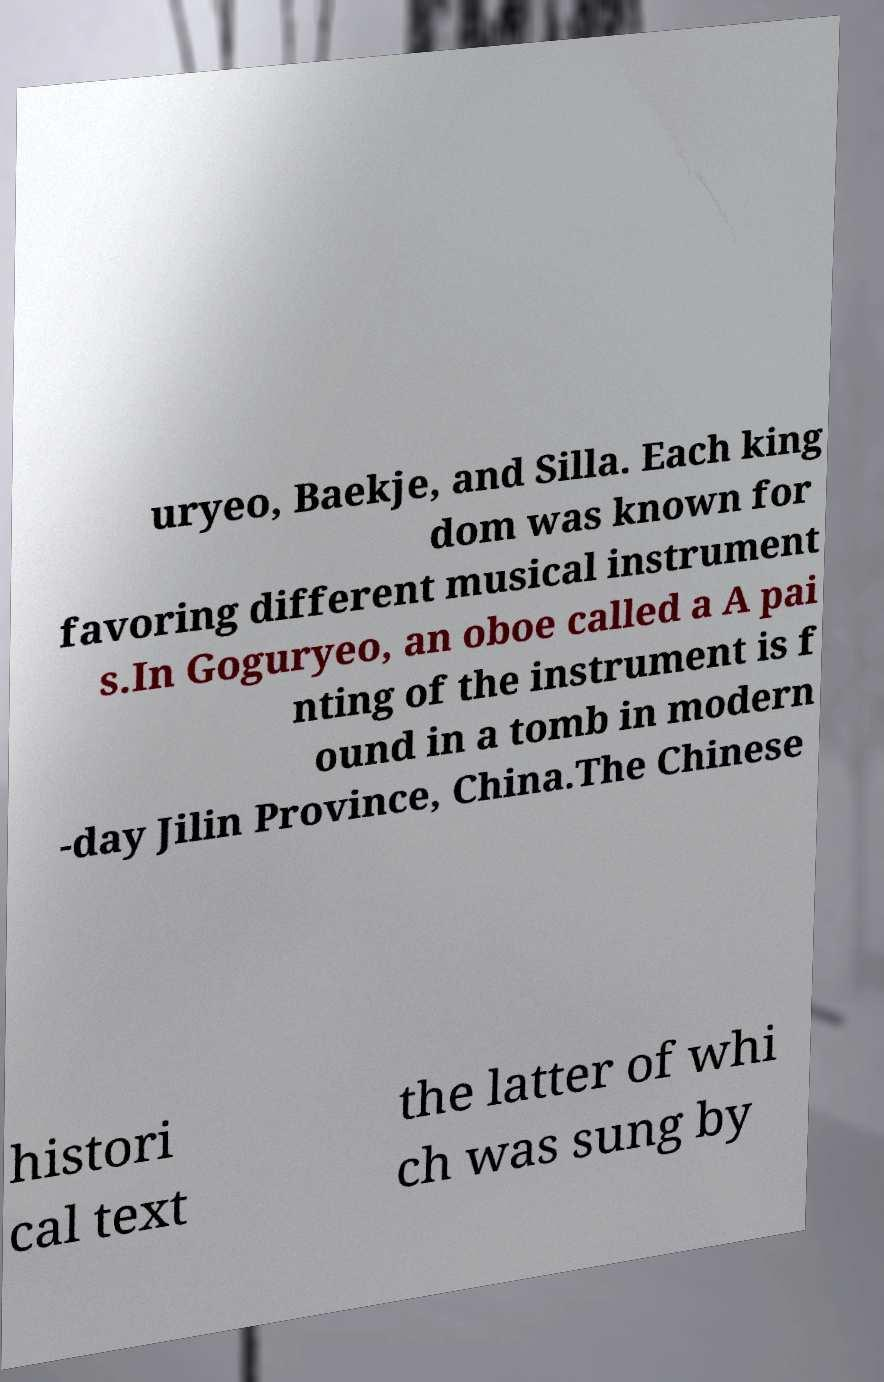Can you read and provide the text displayed in the image?This photo seems to have some interesting text. Can you extract and type it out for me? uryeo, Baekje, and Silla. Each king dom was known for favoring different musical instrument s.In Goguryeo, an oboe called a A pai nting of the instrument is f ound in a tomb in modern -day Jilin Province, China.The Chinese histori cal text the latter of whi ch was sung by 